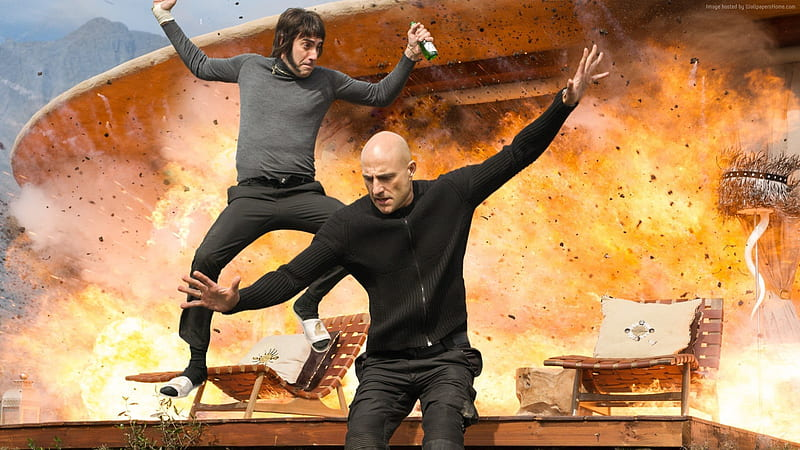Analyze the image in a comprehensive and detailed manner.
 In the midst of a mountainous landscape under a clear blue sky, actor Mark Strong, clad in a black turtleneck and pants, is captured in an action-packed moment. He is leaping off a wooden bench, arms outstretched as if embracing the thrill of the moment. To his left, another individual, dressed in a gray shirt and pants, mirrors his actions, also jumping off the bench with arms wide open. The scene is dominated by a large explosion with vibrant orange and yellow flames, adding an element of danger and excitement to the image. The explosion appears to propel both individuals forward, creating a dynamic and intense atmosphere. 